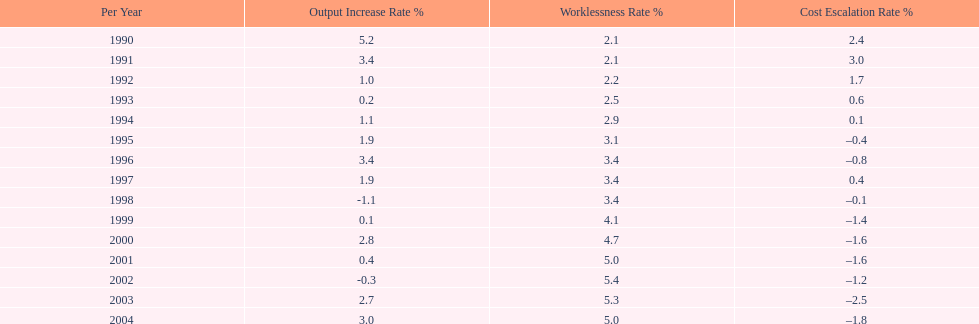Parse the full table. {'header': ['Per Year', 'Output Increase Rate\xa0%', 'Worklessness Rate\xa0%', 'Cost Escalation Rate\xa0%'], 'rows': [['1990', '5.2', '2.1', '2.4'], ['1991', '3.4', '2.1', '3.0'], ['1992', '1.0', '2.2', '1.7'], ['1993', '0.2', '2.5', '0.6'], ['1994', '1.1', '2.9', '0.1'], ['1995', '1.9', '3.1', '–0.4'], ['1996', '3.4', '3.4', '–0.8'], ['1997', '1.9', '3.4', '0.4'], ['1998', '-1.1', '3.4', '–0.1'], ['1999', '0.1', '4.1', '–1.4'], ['2000', '2.8', '4.7', '–1.6'], ['2001', '0.4', '5.0', '–1.6'], ['2002', '-0.3', '5.4', '–1.2'], ['2003', '2.7', '5.3', '–2.5'], ['2004', '3.0', '5.0', '–1.8']]} In what years, between 1990 and 2004, did japan's unemployment rate reach 5% or higher? 4. 